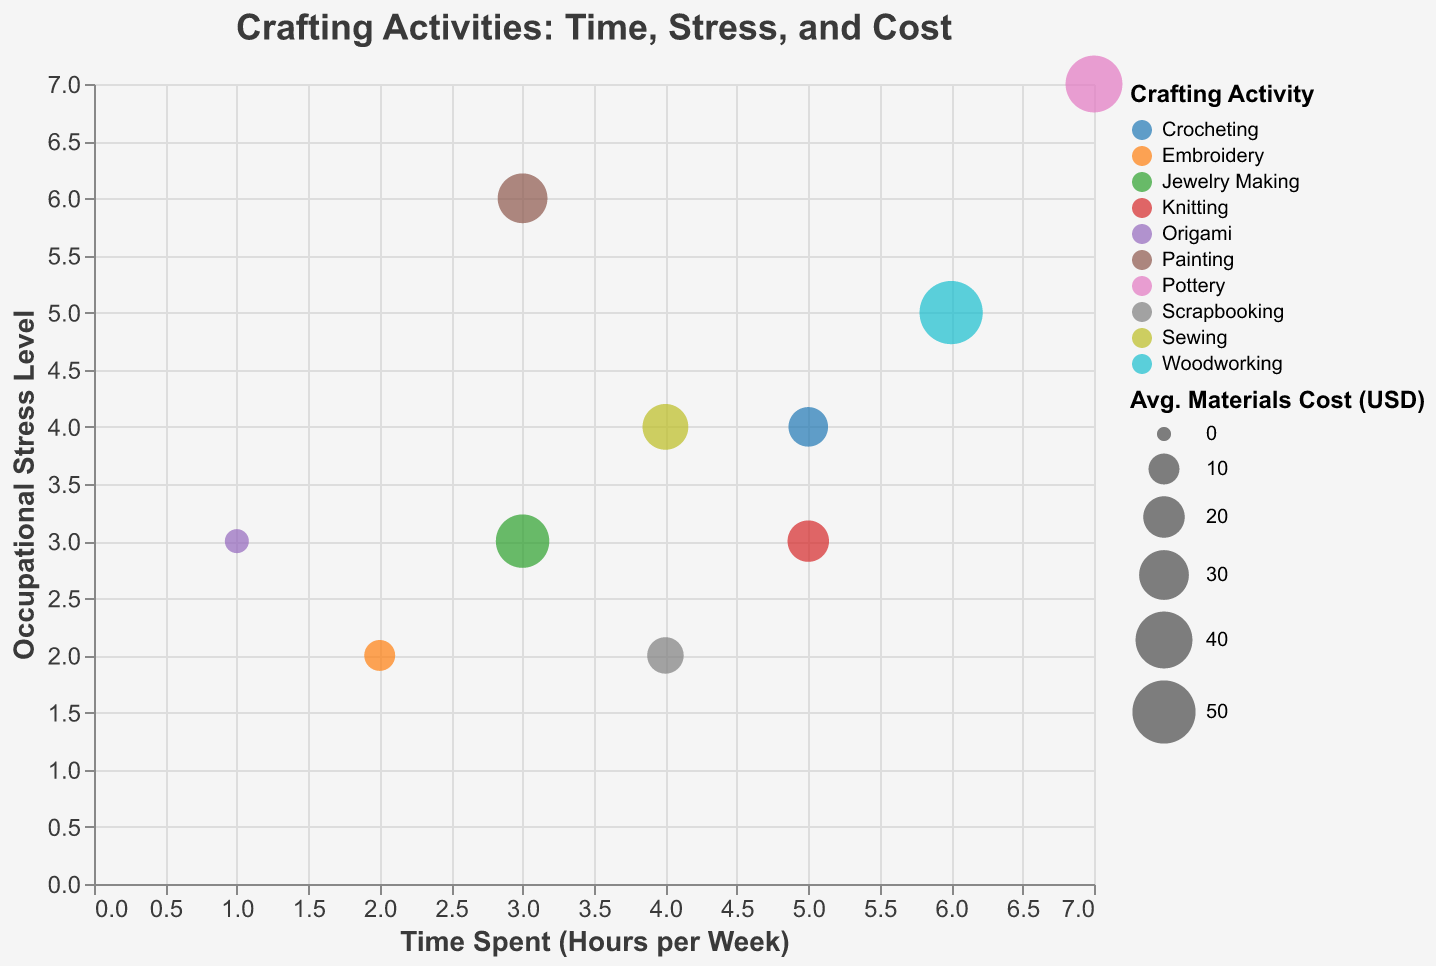How many crafting activities have a stress level of 3 or lower? First, identify the activities with an occupational stress level of 3 or lower. These include Knitting, Scrapbooking, Embroidery, and Origami. There are four such activities.
Answer: 4 Which crafting activity takes the most time per week? Check the "Time Spent (Hours per Week)" field for the highest value, which is Pottery at 7 hours per week.
Answer: Pottery Among crafting activities with an occupational stress level of 4, which one has the lowest average materials cost? Look for activities with a stress level of 4. Then compare their average materials costs. The relevant activities are Sewing and Crocheting, with costs of $25 and $18, respectively. Crocheting has the lower cost.
Answer: Crocheting How does the average materials cost for Origami compare to Jewelry Making? Compare the average materials cost of Origami ($5) and Jewelry Making ($35). Jewelry Making is higher.
Answer: Jewelry Making has a higher cost Which crafting activity has the highest occupational stress level? Identify the crafting activity with the highest value in the "Occupational Stress Level" field. That would be Pottery with a stress level of 7.
Answer: Pottery What’s the average time spent on activities with a stress level greater than 5? First, find the activities with stress levels greater than 5: Painting and Pottery. Their times are 3 and 7 hours per week, respectively. The average is (3+7)/2 = 5.
Answer: 5 hours Is there a crafting activity that takes less than 3 hours per week and has a stress level above 2? Identify activities that take less than 3 hours per week and then check their stress levels. Origami has a stress level of 3, so it fits the criteria.
Answer: Origami Among the listed activities, which one has the smallest average materials cost? Identify the activity with the smallest value in the "Average Materials Cost (USD)" field. Origami has the smallest cost at $5.
Answer: Origami Which crafting activity has the largest bubble size in the chart, and what does it represent? Compare the bubble sizes for different activities, which represent the average materials cost. Woodworking has the largest bubble, indicating the highest cost at $50.
Answer: Woodworking Is there an observable relationship between time spent on crafting activities and occupational stress levels? Observe the bubble chart for any notable trends between the "Time Spent (Hours per Week)" on the x-axis and "Occupational Stress Level" on the y-axis. Overall, there is no clear linear relationship visible in the presented data.
Answer: No clear relationship 